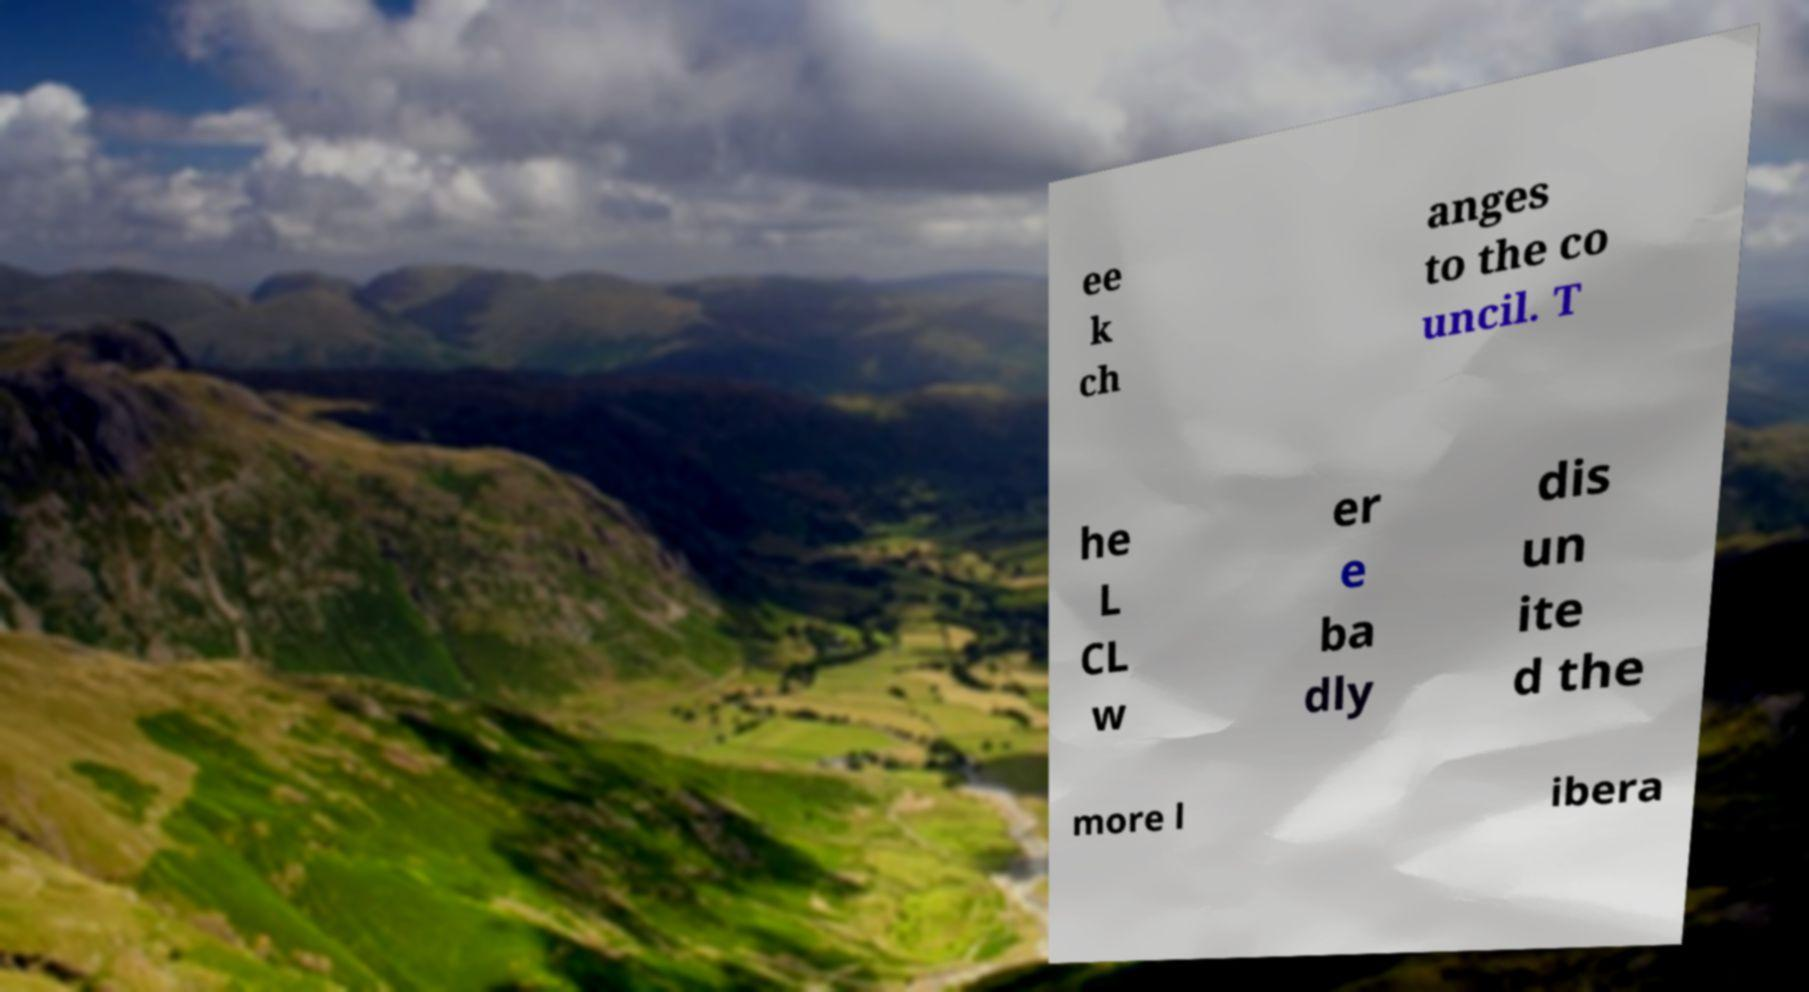Please identify and transcribe the text found in this image. ee k ch anges to the co uncil. T he L CL w er e ba dly dis un ite d the more l ibera 